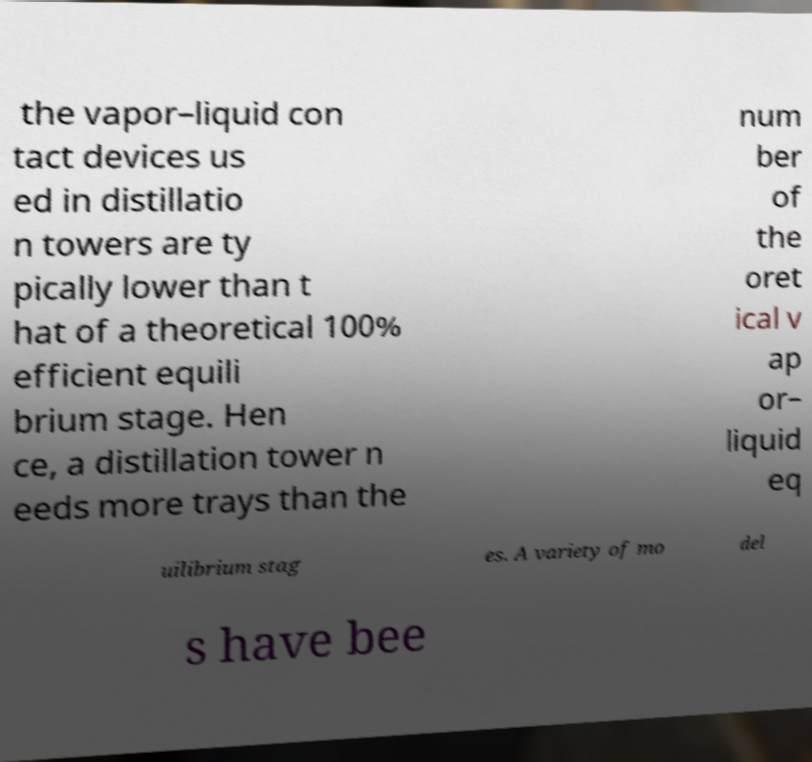There's text embedded in this image that I need extracted. Can you transcribe it verbatim? the vapor–liquid con tact devices us ed in distillatio n towers are ty pically lower than t hat of a theoretical 100% efficient equili brium stage. Hen ce, a distillation tower n eeds more trays than the num ber of the oret ical v ap or– liquid eq uilibrium stag es. A variety of mo del s have bee 